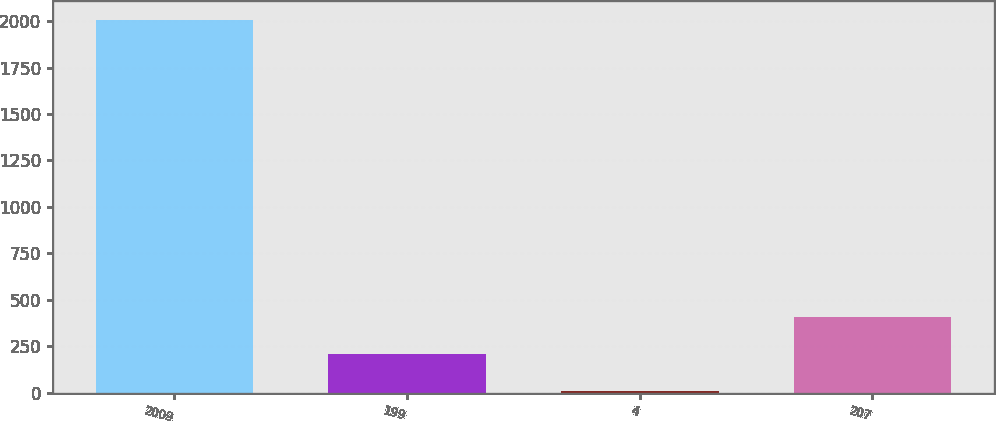Convert chart to OTSL. <chart><loc_0><loc_0><loc_500><loc_500><bar_chart><fcel>2009<fcel>199<fcel>4<fcel>207<nl><fcel>2008<fcel>208.9<fcel>9<fcel>408.8<nl></chart> 